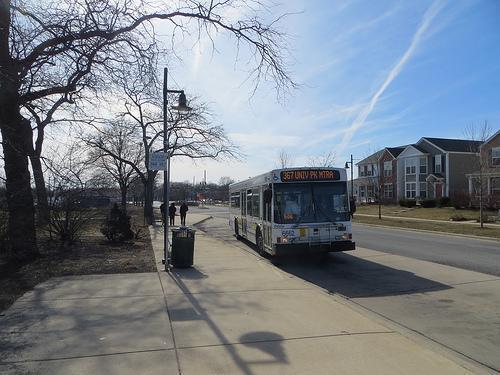How many trash cans are there?
Give a very brief answer. 1. How many elephants are sitting on the bus?
Give a very brief answer. 0. 